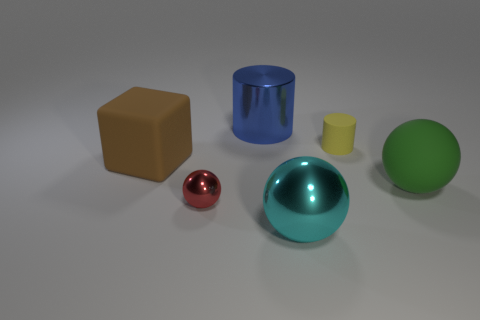There is a small thing behind the large green thing in front of the big thing that is behind the brown cube; what is it made of?
Ensure brevity in your answer.  Rubber. How many cubes are small red metal things or brown things?
Your response must be concise. 1. Is there any other thing that has the same shape as the brown thing?
Provide a succinct answer. No. Is the number of objects that are on the left side of the red thing greater than the number of metal cylinders behind the blue metal object?
Offer a very short reply. Yes. How many cyan balls are in front of the cylinder that is to the left of the small cylinder?
Your response must be concise. 1. What number of things are big blue objects or tiny blue rubber things?
Provide a succinct answer. 1. Is the tiny red metal thing the same shape as the green thing?
Your answer should be compact. Yes. What material is the tiny yellow thing?
Offer a very short reply. Rubber. How many things are in front of the small red thing and on the right side of the small cylinder?
Make the answer very short. 0. Do the block and the green object have the same size?
Ensure brevity in your answer.  Yes. 